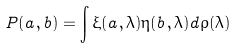Convert formula to latex. <formula><loc_0><loc_0><loc_500><loc_500>P ( a , b ) = \int \xi ( a , \lambda ) \eta ( b , \lambda ) d \rho ( \lambda )</formula> 